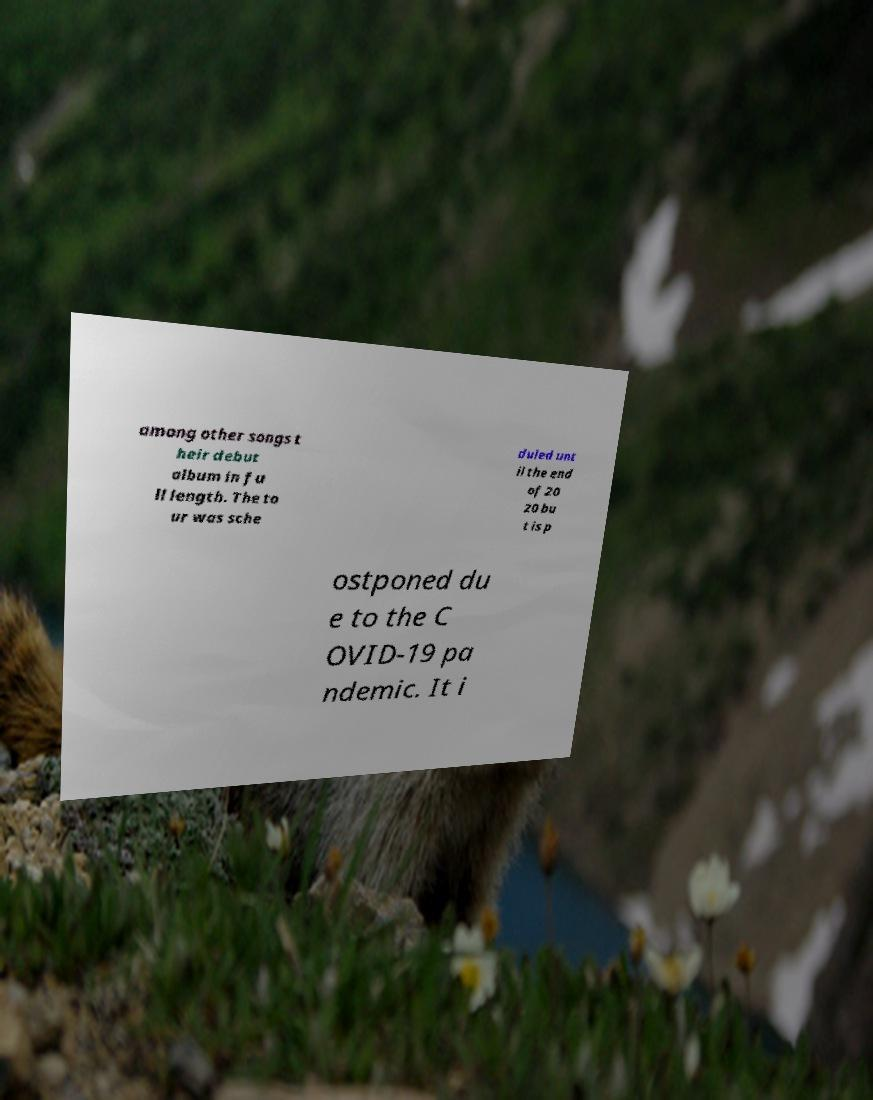Could you assist in decoding the text presented in this image and type it out clearly? among other songs t heir debut album in fu ll length. The to ur was sche duled unt il the end of 20 20 bu t is p ostponed du e to the C OVID-19 pa ndemic. It i 